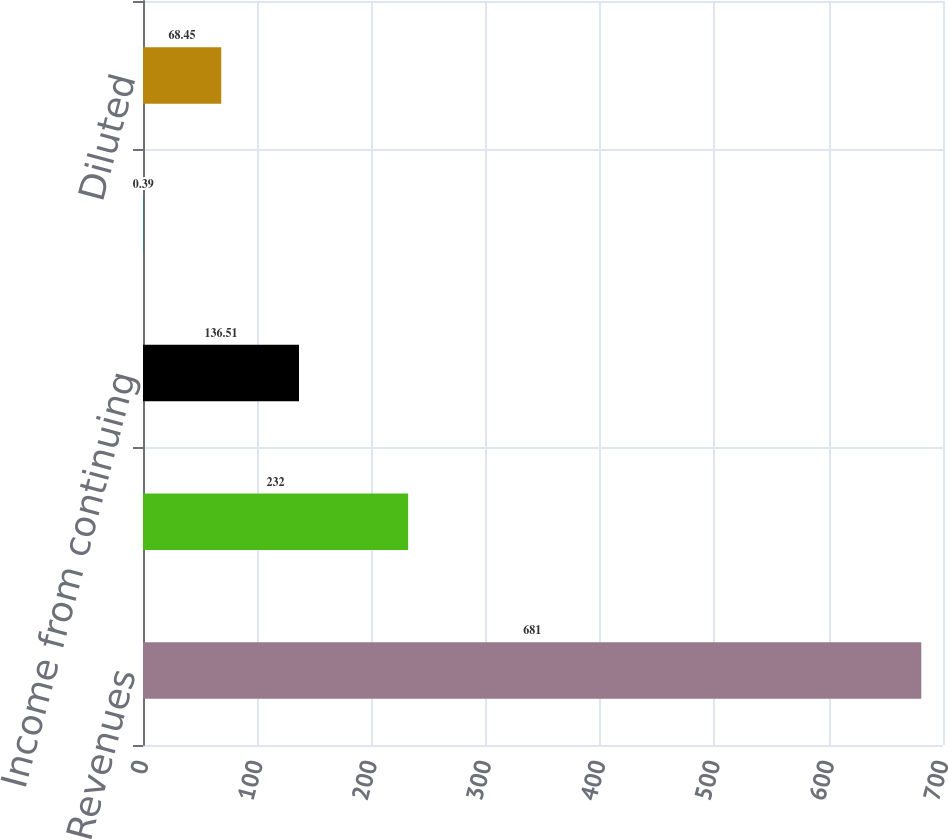Convert chart to OTSL. <chart><loc_0><loc_0><loc_500><loc_500><bar_chart><fcel>Revenues<fcel>Operating income<fcel>Income from continuing<fcel>Basic<fcel>Diluted<nl><fcel>681<fcel>232<fcel>136.51<fcel>0.39<fcel>68.45<nl></chart> 